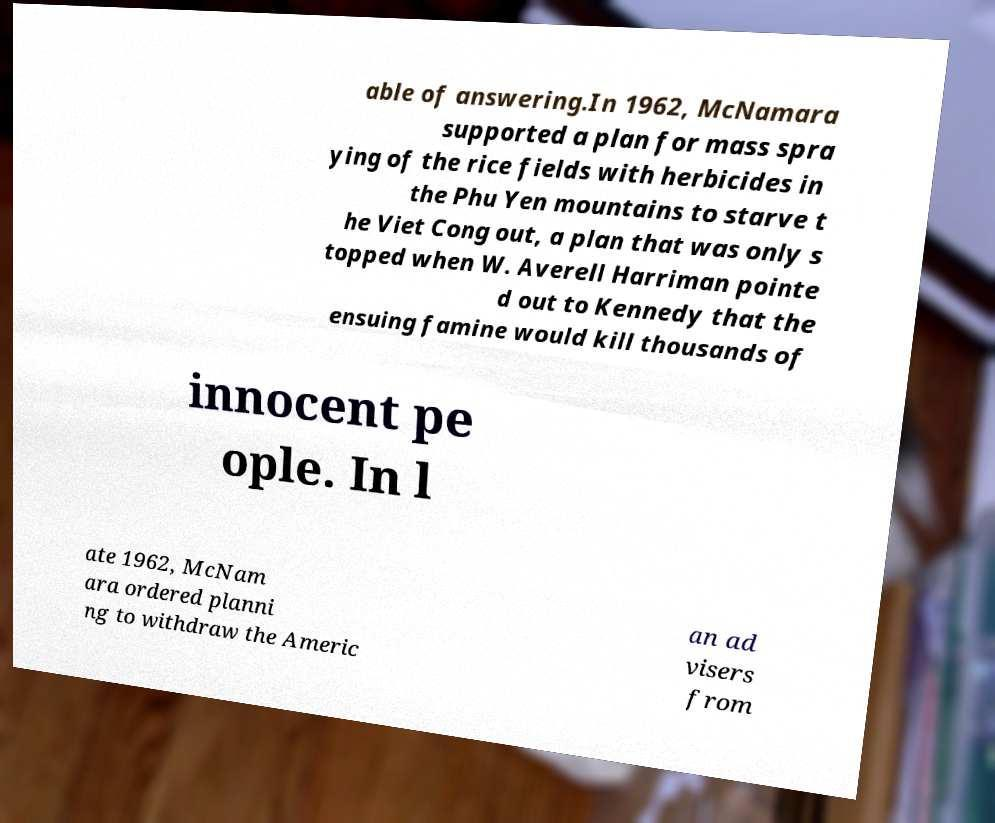Please read and relay the text visible in this image. What does it say? able of answering.In 1962, McNamara supported a plan for mass spra ying of the rice fields with herbicides in the Phu Yen mountains to starve t he Viet Cong out, a plan that was only s topped when W. Averell Harriman pointe d out to Kennedy that the ensuing famine would kill thousands of innocent pe ople. In l ate 1962, McNam ara ordered planni ng to withdraw the Americ an ad visers from 